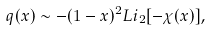Convert formula to latex. <formula><loc_0><loc_0><loc_500><loc_500>q ( x ) \sim { - ( 1 - x ) ^ { 2 } } L i _ { 2 } [ - \chi ( x ) ] ,</formula> 